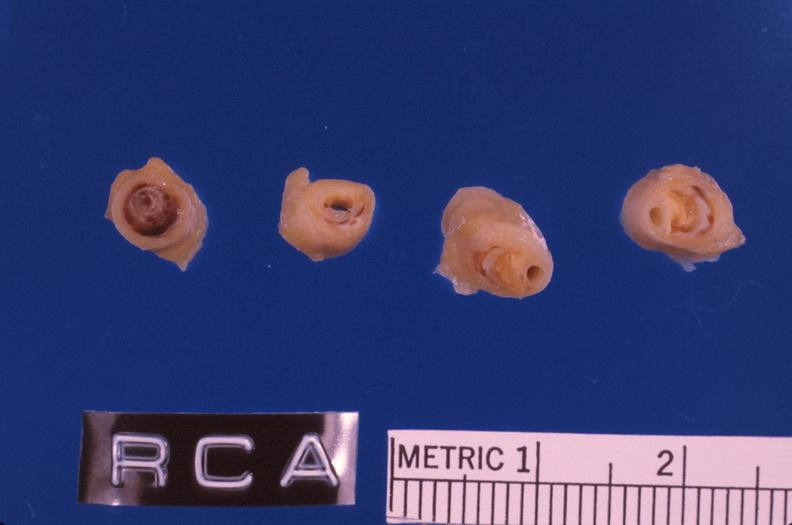what is present?
Answer the question using a single word or phrase. Cardiovascular 